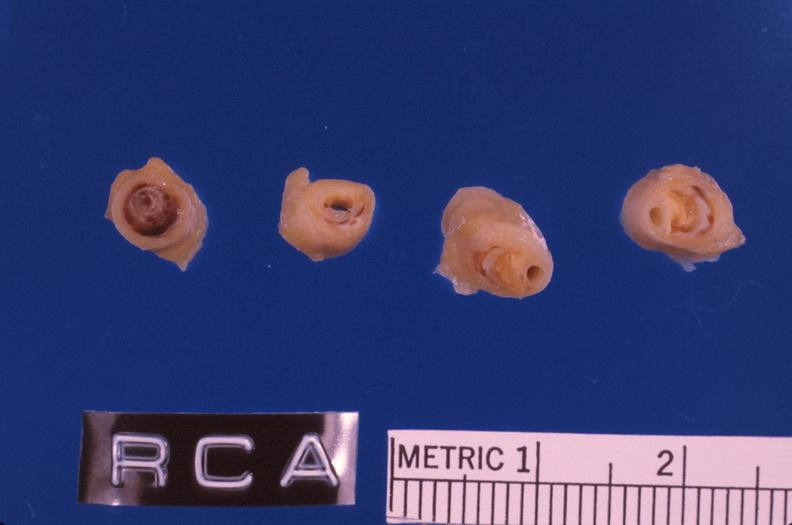what is present?
Answer the question using a single word or phrase. Cardiovascular 